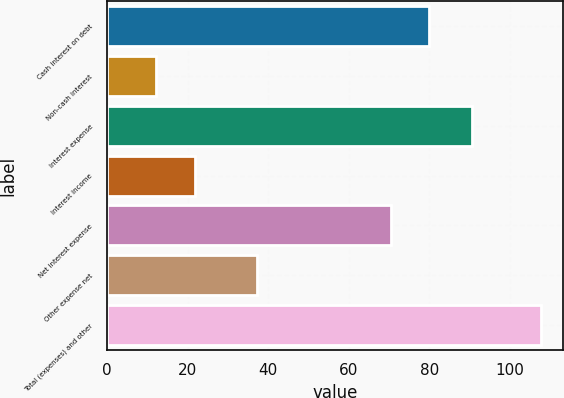Convert chart. <chart><loc_0><loc_0><loc_500><loc_500><bar_chart><fcel>Cash interest on debt<fcel>Non-cash interest<fcel>Interest expense<fcel>Interest income<fcel>Net interest expense<fcel>Other expense net<fcel>Total (expenses) and other<nl><fcel>80.06<fcel>12.2<fcel>90.6<fcel>21.76<fcel>70.5<fcel>37.3<fcel>107.8<nl></chart> 